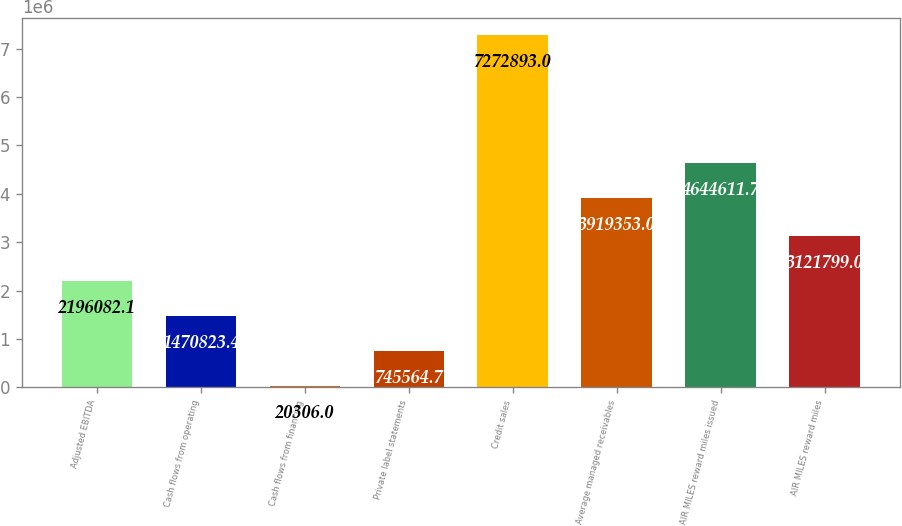Convert chart to OTSL. <chart><loc_0><loc_0><loc_500><loc_500><bar_chart><fcel>Adjusted EBITDA<fcel>Cash flows from operating<fcel>Cash flows from financing<fcel>Private label statements<fcel>Credit sales<fcel>Average managed receivables<fcel>AIR MILES reward miles issued<fcel>AIR MILES reward miles<nl><fcel>2.19608e+06<fcel>1.47082e+06<fcel>20306<fcel>745565<fcel>7.27289e+06<fcel>3.91935e+06<fcel>4.64461e+06<fcel>3.1218e+06<nl></chart> 